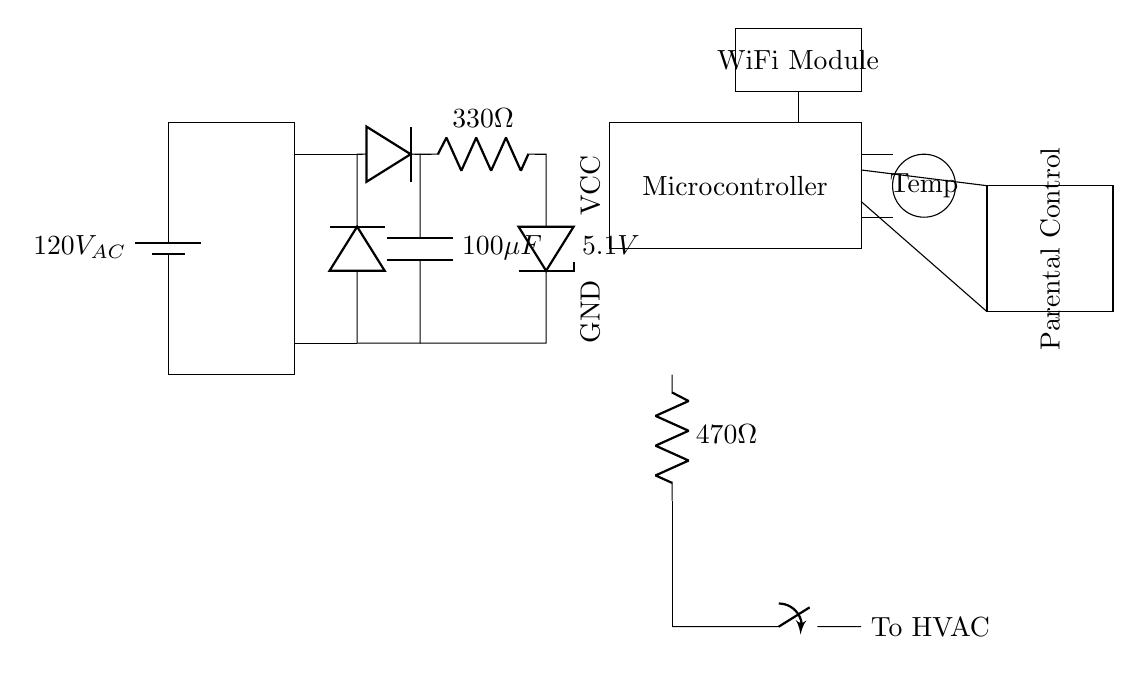What is the input voltage of the circuit? The input voltage is 120V AC, which is indicated at the battery symbol at the beginning of the circuit diagram.
Answer: 120V AC What component is responsible for voltage regulation? The component that regulates the voltage is the voltage regulator, shown as a zener diode labeled as 5.1V in the circuit.
Answer: Zener diode How many ohms is the resistor in the relay section? The resistor in the relay section is labeled as 470 ohms, which can be found near the relay symbol.
Answer: 470 ohms What does the WiFi module connect to in this circuit? The WiFi module connects to the microcontroller, as indicated by the direct line from the module to the microcontroller section.
Answer: Microcontroller What is the role of the temperature sensor in this circuit? The temperature sensor measures the ambient temperature and sends this information to the microcontroller, enabling temperature regulation in the HVAC system.
Answer: Measure temperature How does the parental control feature interact with the microcontroller? The parental control interface connects to the microcontroller with two lines, indicating that it allows user input to control the thermostat settings managed by the microcontroller.
Answer: User input for control What type of switch is used for HVAC control in this circuit? The switch used for HVAC control is a closing switch, which is depicted in the circuit diagram leading to the HVAC system from the relay.
Answer: Closing switch 